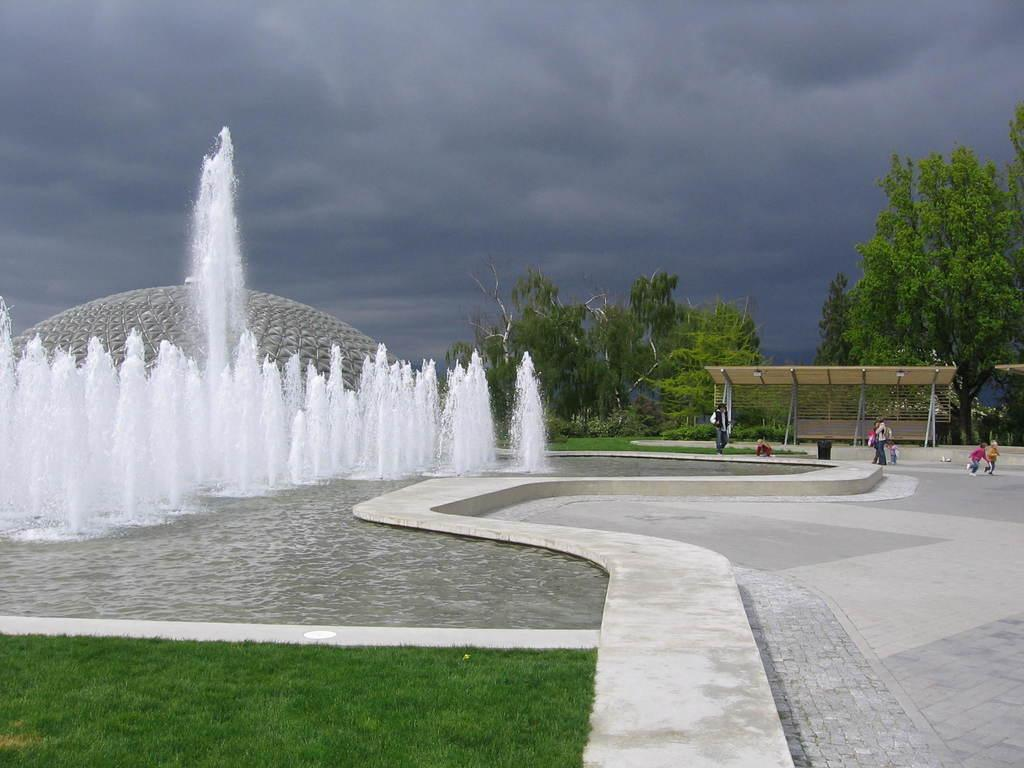What type of vegetation is present in the image? There are trees in the image. What is the water feature in the image? There is a water fountain in the image. What covers the ground in the image? There is grass on the ground in the image. What are the people in the image doing? There are people walking in the image. How would you describe the sky in the image? The sky is blue and cloudy in the image. What is the committee discussing in the image? There is no committee present in the image, so it is not possible to determine what they might be discussing. Can you tell me the weight of the worm in the image? There is no worm present in the image, so it is not possible to determine its weight. 